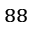<formula> <loc_0><loc_0><loc_500><loc_500>^ { 8 8 }</formula> 